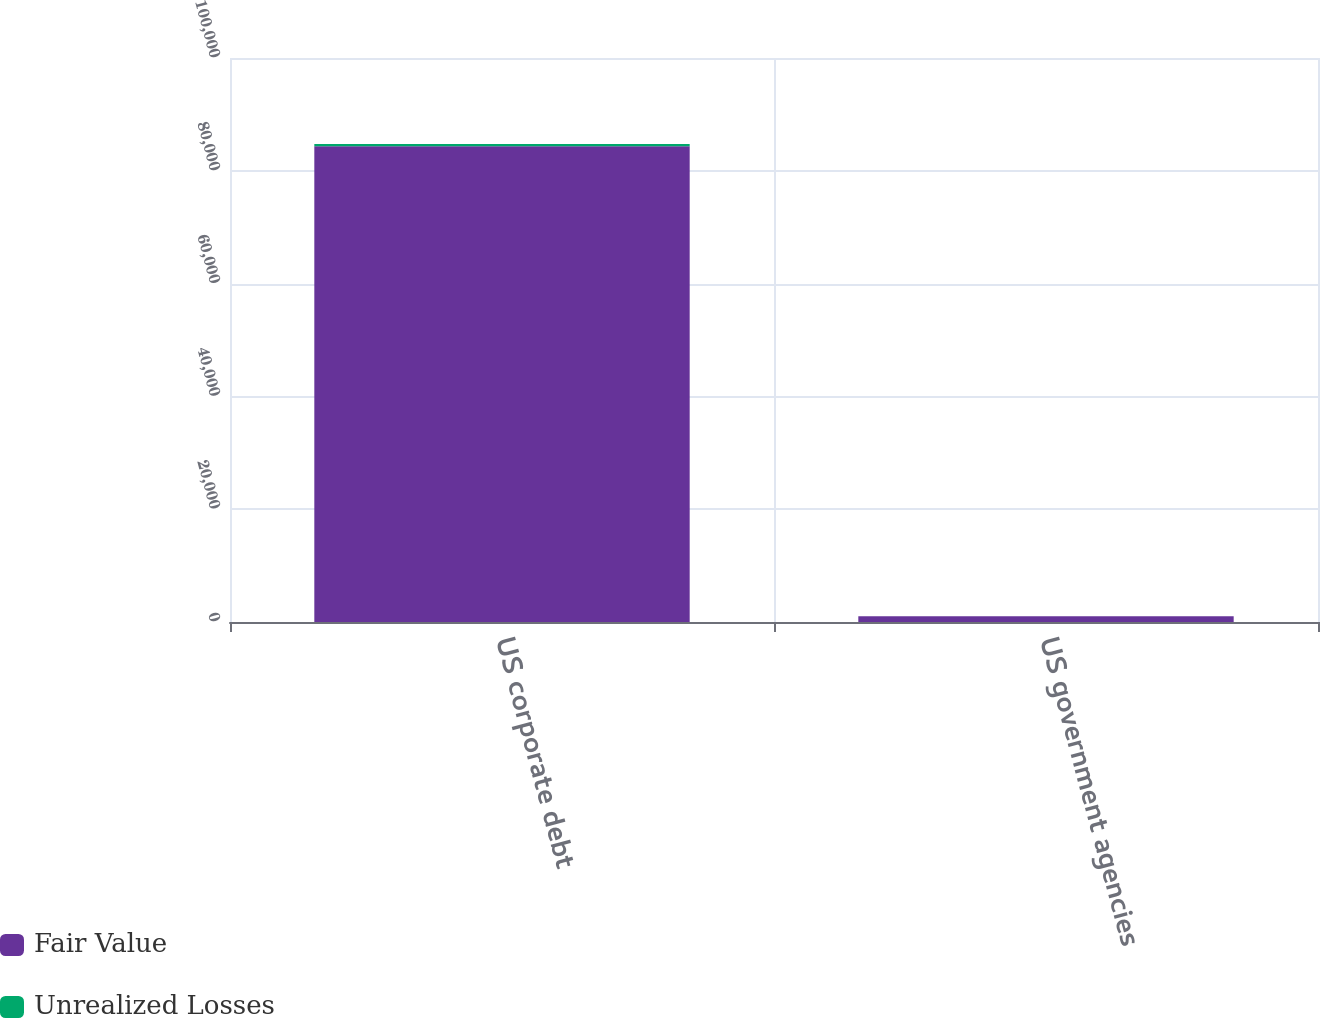Convert chart to OTSL. <chart><loc_0><loc_0><loc_500><loc_500><stacked_bar_chart><ecel><fcel>US corporate debt<fcel>US government agencies<nl><fcel>Fair Value<fcel>84337<fcel>999<nl><fcel>Unrealized Losses<fcel>397<fcel>1<nl></chart> 